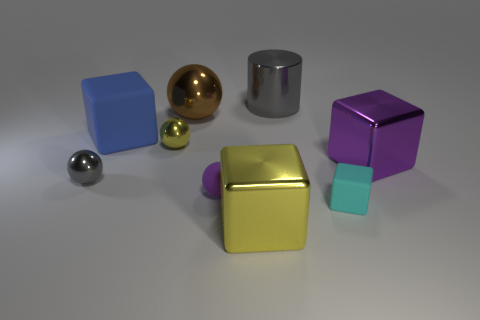Which objects in the image might be lighter or heavier, and why? Assuming materials are consistent with their appearance, the golden sphere and silver cylinder might be heavier due to looking metallic, while the matte blocks could be lighter, possibly made from plastic. The smaller blue cube and the tiny golden ball might be the lightest due to their size. 